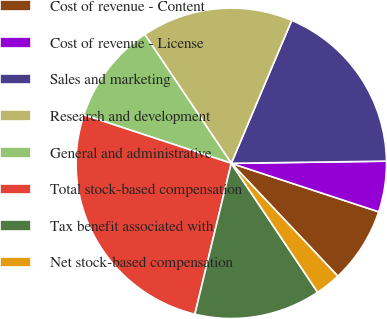<chart> <loc_0><loc_0><loc_500><loc_500><pie_chart><fcel>Cost of revenue - Content<fcel>Cost of revenue - License<fcel>Sales and marketing<fcel>Research and development<fcel>General and administrative<fcel>Total stock-based compensation<fcel>Tax benefit associated with<fcel>Net stock-based compensation<nl><fcel>7.9%<fcel>5.28%<fcel>18.41%<fcel>15.78%<fcel>10.53%<fcel>26.28%<fcel>13.16%<fcel>2.65%<nl></chart> 